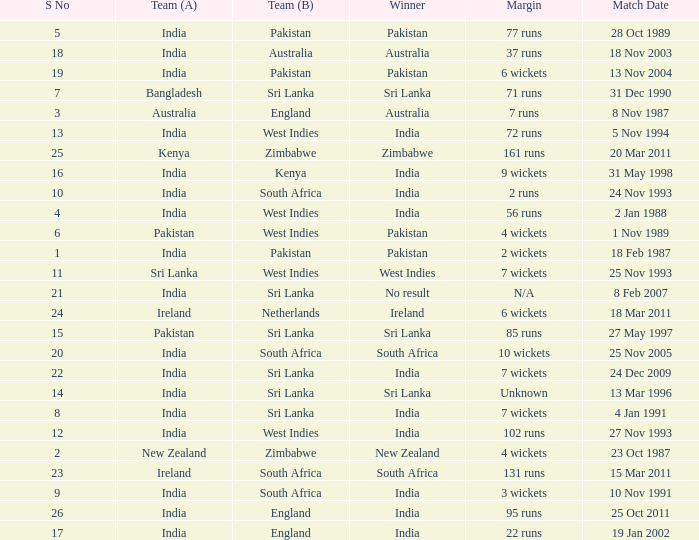What was the margin of the match on 19 Jan 2002? 22 runs. 